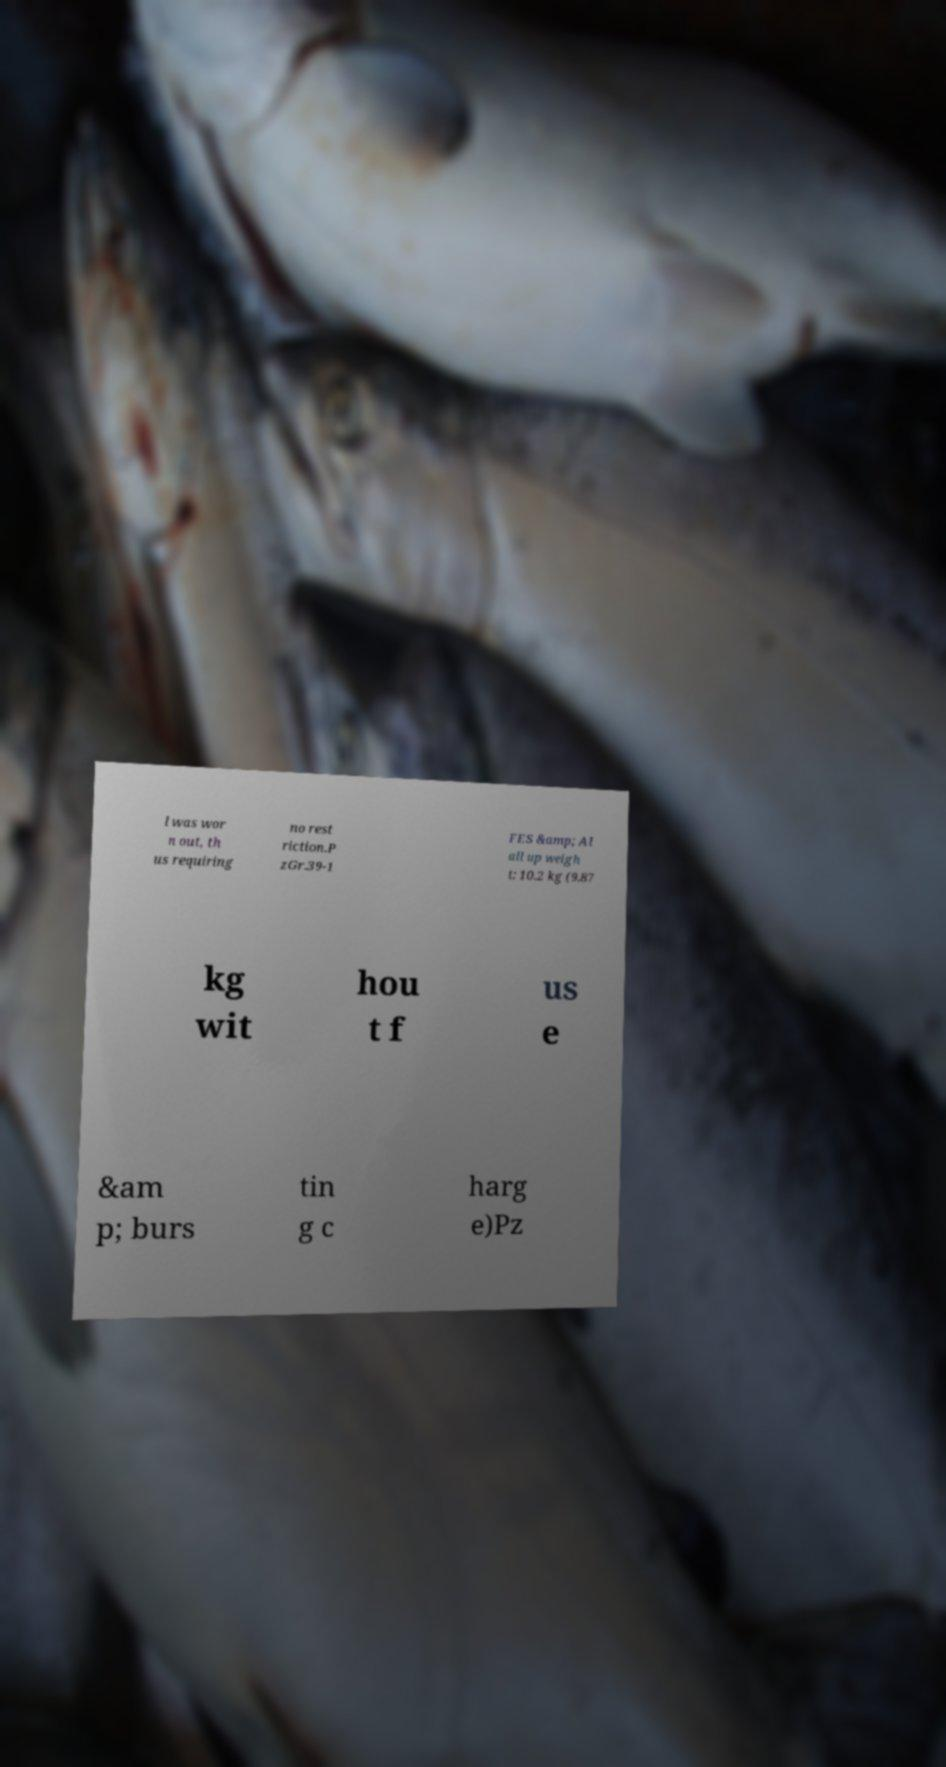For documentation purposes, I need the text within this image transcribed. Could you provide that? l was wor n out, th us requiring no rest riction.P zGr.39-1 FES &amp; Al all up weigh t: 10.2 kg (9.87 kg wit hou t f us e &am p; burs tin g c harg e)Pz 